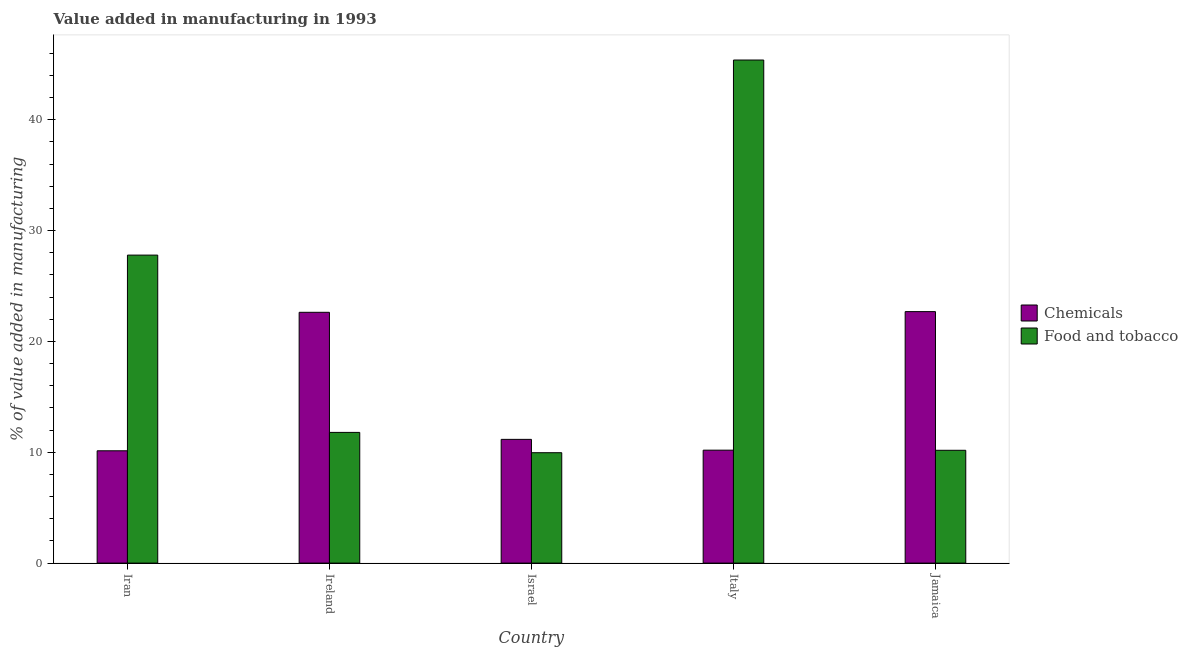How many groups of bars are there?
Provide a succinct answer. 5. Are the number of bars per tick equal to the number of legend labels?
Offer a very short reply. Yes. What is the label of the 3rd group of bars from the left?
Keep it short and to the point. Israel. What is the value added by manufacturing food and tobacco in Italy?
Your answer should be compact. 45.38. Across all countries, what is the maximum value added by manufacturing food and tobacco?
Make the answer very short. 45.38. Across all countries, what is the minimum value added by manufacturing food and tobacco?
Offer a very short reply. 9.96. In which country was the value added by  manufacturing chemicals maximum?
Offer a terse response. Jamaica. What is the total value added by manufacturing food and tobacco in the graph?
Give a very brief answer. 105.09. What is the difference between the value added by manufacturing food and tobacco in Iran and that in Ireland?
Your answer should be compact. 15.99. What is the difference between the value added by manufacturing food and tobacco in Italy and the value added by  manufacturing chemicals in Jamaica?
Provide a succinct answer. 22.7. What is the average value added by  manufacturing chemicals per country?
Provide a succinct answer. 15.36. What is the difference between the value added by manufacturing food and tobacco and value added by  manufacturing chemicals in Ireland?
Ensure brevity in your answer.  -10.83. What is the ratio of the value added by  manufacturing chemicals in Iran to that in Ireland?
Give a very brief answer. 0.45. Is the value added by  manufacturing chemicals in Iran less than that in Israel?
Keep it short and to the point. Yes. Is the difference between the value added by manufacturing food and tobacco in Iran and Israel greater than the difference between the value added by  manufacturing chemicals in Iran and Israel?
Make the answer very short. Yes. What is the difference between the highest and the second highest value added by manufacturing food and tobacco?
Your answer should be compact. 17.6. What is the difference between the highest and the lowest value added by  manufacturing chemicals?
Ensure brevity in your answer.  12.55. In how many countries, is the value added by manufacturing food and tobacco greater than the average value added by manufacturing food and tobacco taken over all countries?
Ensure brevity in your answer.  2. Is the sum of the value added by manufacturing food and tobacco in Italy and Jamaica greater than the maximum value added by  manufacturing chemicals across all countries?
Keep it short and to the point. Yes. What does the 1st bar from the left in Israel represents?
Give a very brief answer. Chemicals. What does the 1st bar from the right in Iran represents?
Ensure brevity in your answer.  Food and tobacco. Are all the bars in the graph horizontal?
Your response must be concise. No. Does the graph contain grids?
Ensure brevity in your answer.  No. Where does the legend appear in the graph?
Your answer should be very brief. Center right. How many legend labels are there?
Give a very brief answer. 2. How are the legend labels stacked?
Your answer should be very brief. Vertical. What is the title of the graph?
Your response must be concise. Value added in manufacturing in 1993. Does "Taxes" appear as one of the legend labels in the graph?
Your answer should be very brief. No. What is the label or title of the X-axis?
Provide a short and direct response. Country. What is the label or title of the Y-axis?
Your answer should be compact. % of value added in manufacturing. What is the % of value added in manufacturing in Chemicals in Iran?
Give a very brief answer. 10.13. What is the % of value added in manufacturing of Food and tobacco in Iran?
Provide a succinct answer. 27.79. What is the % of value added in manufacturing in Chemicals in Ireland?
Keep it short and to the point. 22.62. What is the % of value added in manufacturing in Food and tobacco in Ireland?
Your response must be concise. 11.79. What is the % of value added in manufacturing of Chemicals in Israel?
Offer a very short reply. 11.16. What is the % of value added in manufacturing of Food and tobacco in Israel?
Give a very brief answer. 9.96. What is the % of value added in manufacturing of Chemicals in Italy?
Offer a very short reply. 10.19. What is the % of value added in manufacturing of Food and tobacco in Italy?
Provide a short and direct response. 45.38. What is the % of value added in manufacturing of Chemicals in Jamaica?
Offer a very short reply. 22.69. What is the % of value added in manufacturing of Food and tobacco in Jamaica?
Provide a succinct answer. 10.18. Across all countries, what is the maximum % of value added in manufacturing in Chemicals?
Offer a terse response. 22.69. Across all countries, what is the maximum % of value added in manufacturing of Food and tobacco?
Offer a very short reply. 45.38. Across all countries, what is the minimum % of value added in manufacturing of Chemicals?
Your response must be concise. 10.13. Across all countries, what is the minimum % of value added in manufacturing in Food and tobacco?
Ensure brevity in your answer.  9.96. What is the total % of value added in manufacturing of Chemicals in the graph?
Your answer should be compact. 76.79. What is the total % of value added in manufacturing of Food and tobacco in the graph?
Give a very brief answer. 105.09. What is the difference between the % of value added in manufacturing of Chemicals in Iran and that in Ireland?
Keep it short and to the point. -12.49. What is the difference between the % of value added in manufacturing of Food and tobacco in Iran and that in Ireland?
Provide a succinct answer. 15.99. What is the difference between the % of value added in manufacturing in Chemicals in Iran and that in Israel?
Your answer should be very brief. -1.03. What is the difference between the % of value added in manufacturing of Food and tobacco in Iran and that in Israel?
Offer a very short reply. 17.83. What is the difference between the % of value added in manufacturing of Chemicals in Iran and that in Italy?
Ensure brevity in your answer.  -0.06. What is the difference between the % of value added in manufacturing in Food and tobacco in Iran and that in Italy?
Offer a terse response. -17.6. What is the difference between the % of value added in manufacturing of Chemicals in Iran and that in Jamaica?
Ensure brevity in your answer.  -12.55. What is the difference between the % of value added in manufacturing of Food and tobacco in Iran and that in Jamaica?
Offer a terse response. 17.61. What is the difference between the % of value added in manufacturing in Chemicals in Ireland and that in Israel?
Ensure brevity in your answer.  11.46. What is the difference between the % of value added in manufacturing in Food and tobacco in Ireland and that in Israel?
Your answer should be very brief. 1.83. What is the difference between the % of value added in manufacturing in Chemicals in Ireland and that in Italy?
Offer a terse response. 12.44. What is the difference between the % of value added in manufacturing of Food and tobacco in Ireland and that in Italy?
Offer a very short reply. -33.59. What is the difference between the % of value added in manufacturing in Chemicals in Ireland and that in Jamaica?
Your answer should be very brief. -0.06. What is the difference between the % of value added in manufacturing in Food and tobacco in Ireland and that in Jamaica?
Provide a short and direct response. 1.61. What is the difference between the % of value added in manufacturing in Chemicals in Israel and that in Italy?
Make the answer very short. 0.97. What is the difference between the % of value added in manufacturing in Food and tobacco in Israel and that in Italy?
Provide a succinct answer. -35.42. What is the difference between the % of value added in manufacturing in Chemicals in Israel and that in Jamaica?
Your answer should be compact. -11.52. What is the difference between the % of value added in manufacturing of Food and tobacco in Israel and that in Jamaica?
Your answer should be very brief. -0.22. What is the difference between the % of value added in manufacturing in Chemicals in Italy and that in Jamaica?
Offer a very short reply. -12.5. What is the difference between the % of value added in manufacturing of Food and tobacco in Italy and that in Jamaica?
Provide a succinct answer. 35.21. What is the difference between the % of value added in manufacturing of Chemicals in Iran and the % of value added in manufacturing of Food and tobacco in Ireland?
Your response must be concise. -1.66. What is the difference between the % of value added in manufacturing in Chemicals in Iran and the % of value added in manufacturing in Food and tobacco in Israel?
Provide a short and direct response. 0.17. What is the difference between the % of value added in manufacturing in Chemicals in Iran and the % of value added in manufacturing in Food and tobacco in Italy?
Offer a terse response. -35.25. What is the difference between the % of value added in manufacturing in Chemicals in Iran and the % of value added in manufacturing in Food and tobacco in Jamaica?
Ensure brevity in your answer.  -0.04. What is the difference between the % of value added in manufacturing in Chemicals in Ireland and the % of value added in manufacturing in Food and tobacco in Israel?
Give a very brief answer. 12.67. What is the difference between the % of value added in manufacturing in Chemicals in Ireland and the % of value added in manufacturing in Food and tobacco in Italy?
Give a very brief answer. -22.76. What is the difference between the % of value added in manufacturing in Chemicals in Ireland and the % of value added in manufacturing in Food and tobacco in Jamaica?
Provide a succinct answer. 12.45. What is the difference between the % of value added in manufacturing in Chemicals in Israel and the % of value added in manufacturing in Food and tobacco in Italy?
Offer a very short reply. -34.22. What is the difference between the % of value added in manufacturing of Chemicals in Italy and the % of value added in manufacturing of Food and tobacco in Jamaica?
Offer a very short reply. 0.01. What is the average % of value added in manufacturing in Chemicals per country?
Make the answer very short. 15.36. What is the average % of value added in manufacturing in Food and tobacco per country?
Provide a short and direct response. 21.02. What is the difference between the % of value added in manufacturing in Chemicals and % of value added in manufacturing in Food and tobacco in Iran?
Your answer should be very brief. -17.65. What is the difference between the % of value added in manufacturing in Chemicals and % of value added in manufacturing in Food and tobacco in Ireland?
Your answer should be very brief. 10.83. What is the difference between the % of value added in manufacturing of Chemicals and % of value added in manufacturing of Food and tobacco in Israel?
Provide a succinct answer. 1.2. What is the difference between the % of value added in manufacturing of Chemicals and % of value added in manufacturing of Food and tobacco in Italy?
Provide a short and direct response. -35.19. What is the difference between the % of value added in manufacturing of Chemicals and % of value added in manufacturing of Food and tobacco in Jamaica?
Offer a terse response. 12.51. What is the ratio of the % of value added in manufacturing of Chemicals in Iran to that in Ireland?
Give a very brief answer. 0.45. What is the ratio of the % of value added in manufacturing in Food and tobacco in Iran to that in Ireland?
Provide a succinct answer. 2.36. What is the ratio of the % of value added in manufacturing in Chemicals in Iran to that in Israel?
Your response must be concise. 0.91. What is the ratio of the % of value added in manufacturing of Food and tobacco in Iran to that in Israel?
Make the answer very short. 2.79. What is the ratio of the % of value added in manufacturing in Chemicals in Iran to that in Italy?
Your answer should be compact. 0.99. What is the ratio of the % of value added in manufacturing of Food and tobacco in Iran to that in Italy?
Ensure brevity in your answer.  0.61. What is the ratio of the % of value added in manufacturing of Chemicals in Iran to that in Jamaica?
Keep it short and to the point. 0.45. What is the ratio of the % of value added in manufacturing of Food and tobacco in Iran to that in Jamaica?
Ensure brevity in your answer.  2.73. What is the ratio of the % of value added in manufacturing of Chemicals in Ireland to that in Israel?
Offer a very short reply. 2.03. What is the ratio of the % of value added in manufacturing of Food and tobacco in Ireland to that in Israel?
Your response must be concise. 1.18. What is the ratio of the % of value added in manufacturing in Chemicals in Ireland to that in Italy?
Your answer should be compact. 2.22. What is the ratio of the % of value added in manufacturing in Food and tobacco in Ireland to that in Italy?
Provide a succinct answer. 0.26. What is the ratio of the % of value added in manufacturing in Chemicals in Ireland to that in Jamaica?
Your answer should be compact. 1. What is the ratio of the % of value added in manufacturing of Food and tobacco in Ireland to that in Jamaica?
Ensure brevity in your answer.  1.16. What is the ratio of the % of value added in manufacturing in Chemicals in Israel to that in Italy?
Your answer should be compact. 1.1. What is the ratio of the % of value added in manufacturing in Food and tobacco in Israel to that in Italy?
Offer a terse response. 0.22. What is the ratio of the % of value added in manufacturing of Chemicals in Israel to that in Jamaica?
Your answer should be very brief. 0.49. What is the ratio of the % of value added in manufacturing in Food and tobacco in Israel to that in Jamaica?
Offer a terse response. 0.98. What is the ratio of the % of value added in manufacturing of Chemicals in Italy to that in Jamaica?
Give a very brief answer. 0.45. What is the ratio of the % of value added in manufacturing in Food and tobacco in Italy to that in Jamaica?
Keep it short and to the point. 4.46. What is the difference between the highest and the second highest % of value added in manufacturing of Chemicals?
Provide a short and direct response. 0.06. What is the difference between the highest and the second highest % of value added in manufacturing of Food and tobacco?
Your answer should be compact. 17.6. What is the difference between the highest and the lowest % of value added in manufacturing in Chemicals?
Offer a terse response. 12.55. What is the difference between the highest and the lowest % of value added in manufacturing in Food and tobacco?
Provide a short and direct response. 35.42. 